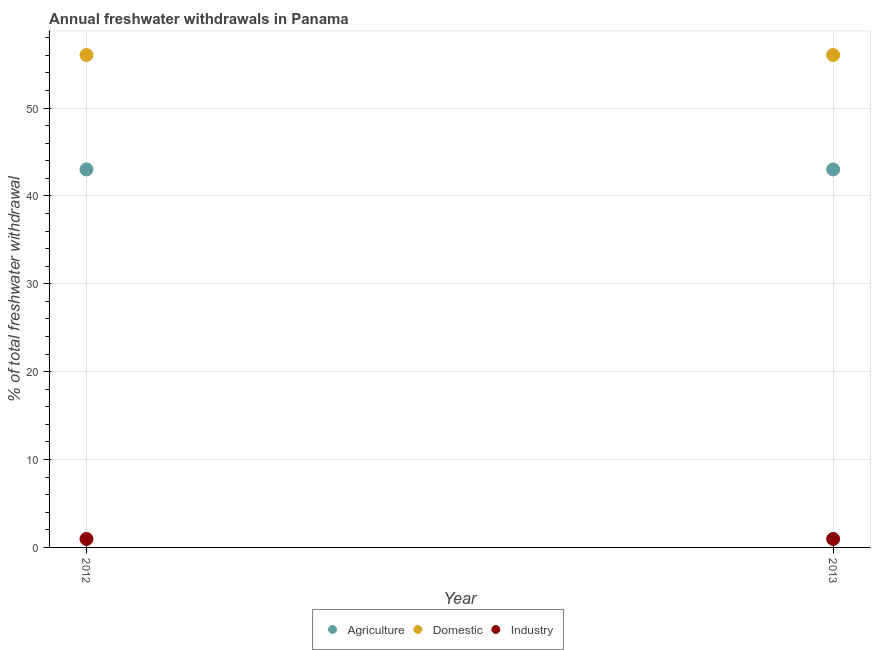How many different coloured dotlines are there?
Make the answer very short. 3. Is the number of dotlines equal to the number of legend labels?
Your answer should be compact. Yes. Across all years, what is the maximum percentage of freshwater withdrawal for domestic purposes?
Your answer should be very brief. 56.03. Across all years, what is the minimum percentage of freshwater withdrawal for domestic purposes?
Your answer should be compact. 56.03. In which year was the percentage of freshwater withdrawal for industry minimum?
Provide a short and direct response. 2012. What is the total percentage of freshwater withdrawal for industry in the graph?
Ensure brevity in your answer.  1.93. What is the difference between the percentage of freshwater withdrawal for agriculture in 2013 and the percentage of freshwater withdrawal for domestic purposes in 2012?
Give a very brief answer. -13.02. What is the average percentage of freshwater withdrawal for domestic purposes per year?
Offer a very short reply. 56.03. In the year 2013, what is the difference between the percentage of freshwater withdrawal for agriculture and percentage of freshwater withdrawal for domestic purposes?
Ensure brevity in your answer.  -13.02. In how many years, is the percentage of freshwater withdrawal for domestic purposes greater than 50 %?
Offer a terse response. 2. Is the percentage of freshwater withdrawal for agriculture in 2012 less than that in 2013?
Provide a short and direct response. No. Is it the case that in every year, the sum of the percentage of freshwater withdrawal for agriculture and percentage of freshwater withdrawal for domestic purposes is greater than the percentage of freshwater withdrawal for industry?
Provide a short and direct response. Yes. Is the percentage of freshwater withdrawal for agriculture strictly less than the percentage of freshwater withdrawal for industry over the years?
Keep it short and to the point. No. How many dotlines are there?
Offer a very short reply. 3. What is the difference between two consecutive major ticks on the Y-axis?
Offer a very short reply. 10. What is the title of the graph?
Give a very brief answer. Annual freshwater withdrawals in Panama. What is the label or title of the Y-axis?
Provide a succinct answer. % of total freshwater withdrawal. What is the % of total freshwater withdrawal of Agriculture in 2012?
Offer a terse response. 43.01. What is the % of total freshwater withdrawal of Domestic in 2012?
Ensure brevity in your answer.  56.03. What is the % of total freshwater withdrawal in Agriculture in 2013?
Give a very brief answer. 43.01. What is the % of total freshwater withdrawal of Domestic in 2013?
Your response must be concise. 56.03. What is the % of total freshwater withdrawal of Industry in 2013?
Your answer should be compact. 0.96. Across all years, what is the maximum % of total freshwater withdrawal of Agriculture?
Make the answer very short. 43.01. Across all years, what is the maximum % of total freshwater withdrawal of Domestic?
Make the answer very short. 56.03. Across all years, what is the minimum % of total freshwater withdrawal in Agriculture?
Offer a very short reply. 43.01. Across all years, what is the minimum % of total freshwater withdrawal of Domestic?
Your response must be concise. 56.03. Across all years, what is the minimum % of total freshwater withdrawal in Industry?
Provide a succinct answer. 0.96. What is the total % of total freshwater withdrawal in Agriculture in the graph?
Ensure brevity in your answer.  86.02. What is the total % of total freshwater withdrawal of Domestic in the graph?
Keep it short and to the point. 112.06. What is the total % of total freshwater withdrawal in Industry in the graph?
Ensure brevity in your answer.  1.93. What is the difference between the % of total freshwater withdrawal of Domestic in 2012 and that in 2013?
Provide a succinct answer. 0. What is the difference between the % of total freshwater withdrawal in Industry in 2012 and that in 2013?
Your response must be concise. 0. What is the difference between the % of total freshwater withdrawal of Agriculture in 2012 and the % of total freshwater withdrawal of Domestic in 2013?
Keep it short and to the point. -13.02. What is the difference between the % of total freshwater withdrawal of Agriculture in 2012 and the % of total freshwater withdrawal of Industry in 2013?
Offer a very short reply. 42.05. What is the difference between the % of total freshwater withdrawal of Domestic in 2012 and the % of total freshwater withdrawal of Industry in 2013?
Keep it short and to the point. 55.07. What is the average % of total freshwater withdrawal in Agriculture per year?
Make the answer very short. 43.01. What is the average % of total freshwater withdrawal in Domestic per year?
Make the answer very short. 56.03. In the year 2012, what is the difference between the % of total freshwater withdrawal in Agriculture and % of total freshwater withdrawal in Domestic?
Make the answer very short. -13.02. In the year 2012, what is the difference between the % of total freshwater withdrawal of Agriculture and % of total freshwater withdrawal of Industry?
Offer a very short reply. 42.05. In the year 2012, what is the difference between the % of total freshwater withdrawal in Domestic and % of total freshwater withdrawal in Industry?
Give a very brief answer. 55.07. In the year 2013, what is the difference between the % of total freshwater withdrawal of Agriculture and % of total freshwater withdrawal of Domestic?
Your answer should be compact. -13.02. In the year 2013, what is the difference between the % of total freshwater withdrawal of Agriculture and % of total freshwater withdrawal of Industry?
Make the answer very short. 42.05. In the year 2013, what is the difference between the % of total freshwater withdrawal of Domestic and % of total freshwater withdrawal of Industry?
Ensure brevity in your answer.  55.07. What is the ratio of the % of total freshwater withdrawal of Industry in 2012 to that in 2013?
Give a very brief answer. 1. What is the difference between the highest and the second highest % of total freshwater withdrawal of Agriculture?
Your answer should be compact. 0. What is the difference between the highest and the lowest % of total freshwater withdrawal in Domestic?
Your response must be concise. 0. What is the difference between the highest and the lowest % of total freshwater withdrawal of Industry?
Offer a terse response. 0. 